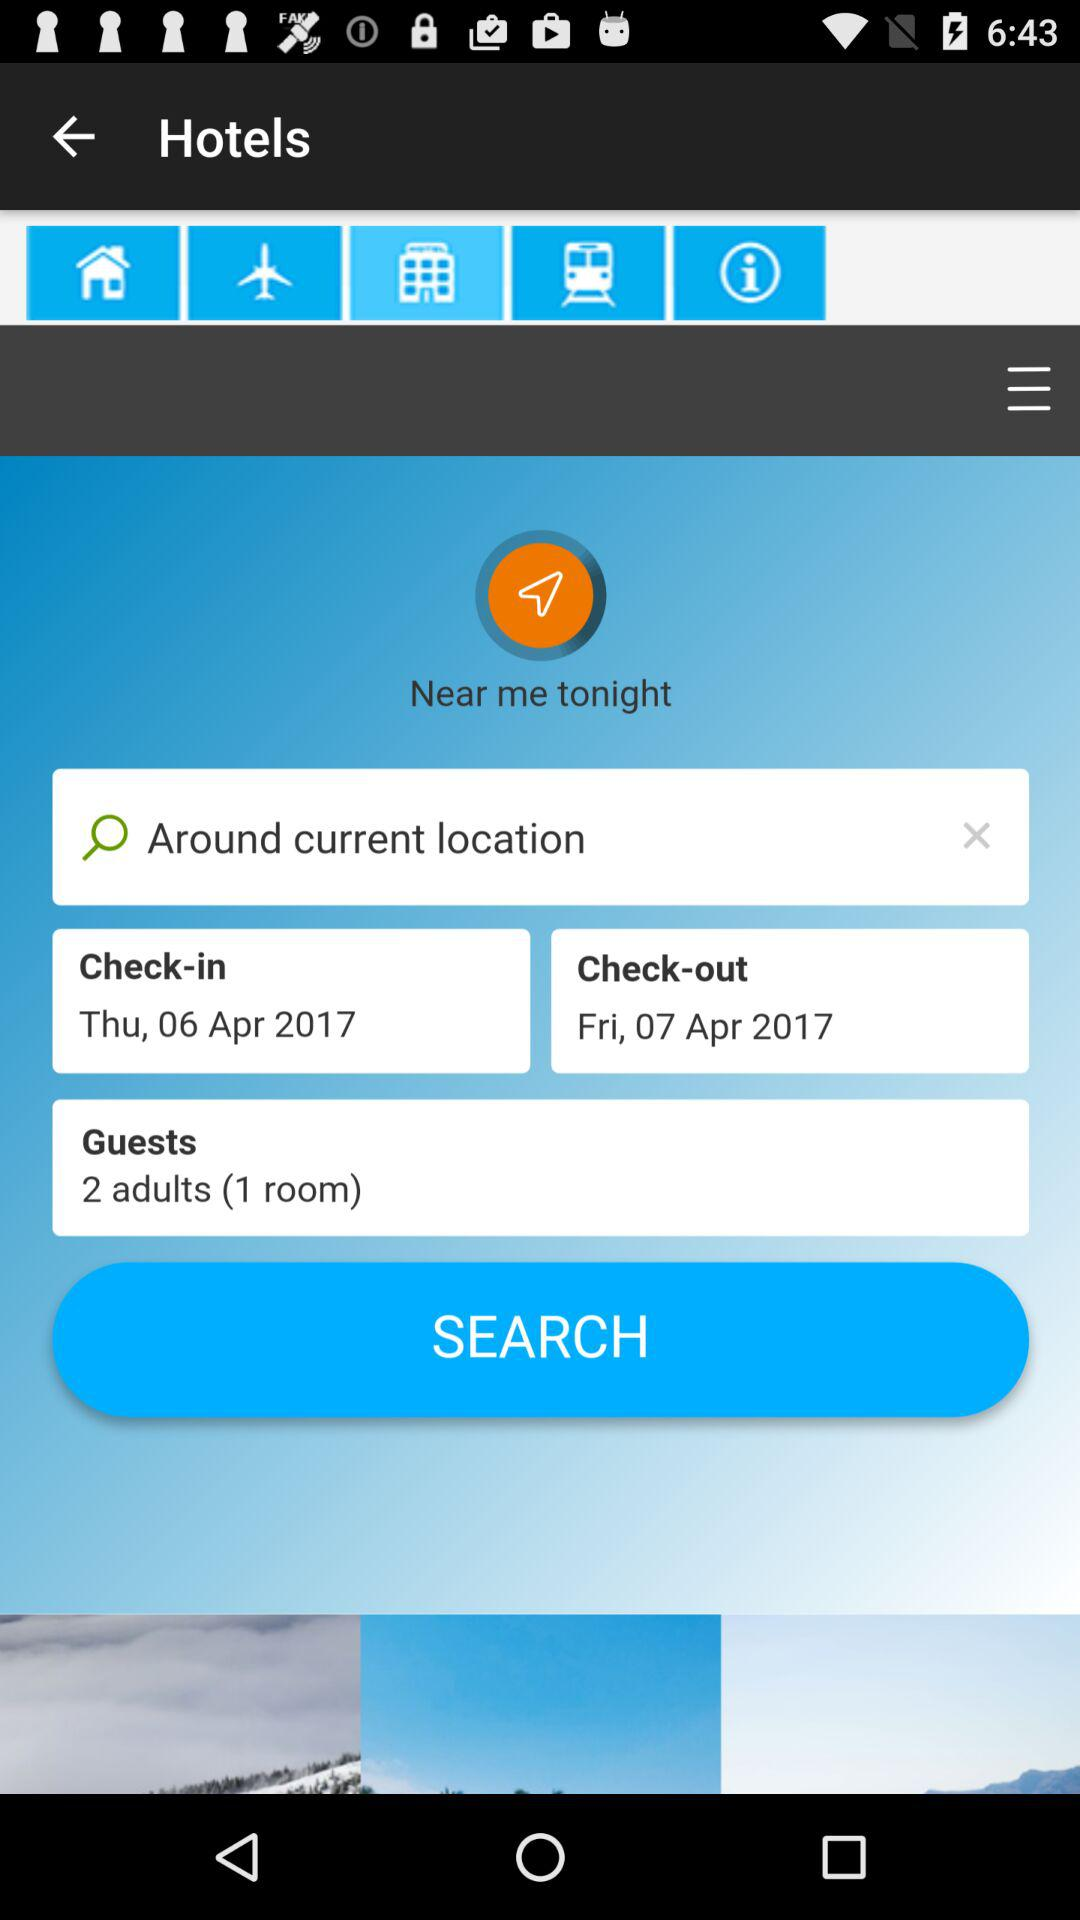How many rooms are being booked?
Answer the question using a single word or phrase. 1 